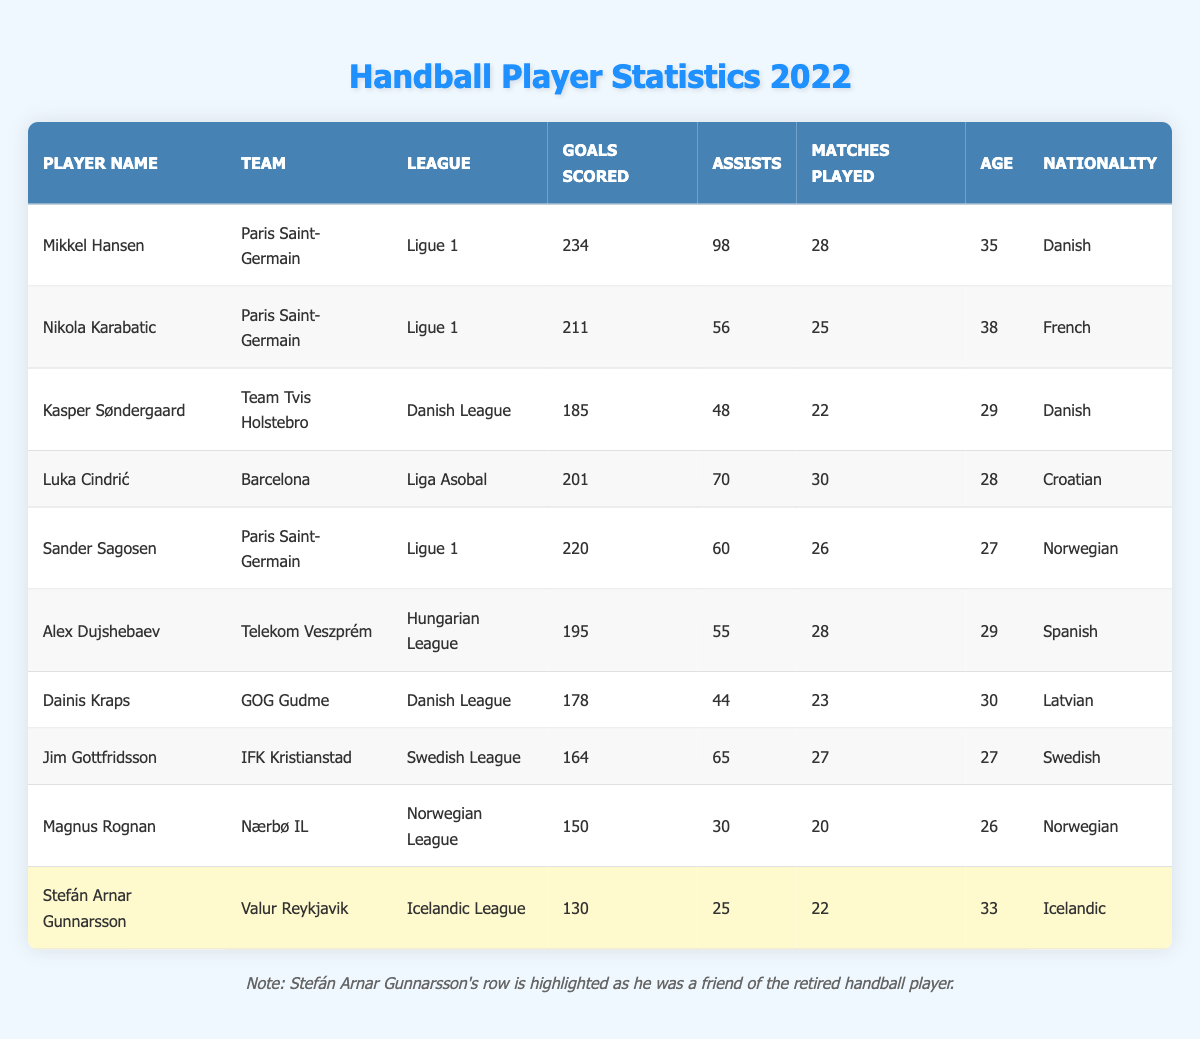What is the total number of goals scored by Mikkel Hansen? Mikkel Hansen's goals scored can be found directly in his row of the table. He scored 234 goals.
Answer: 234 Which player has the most assists in the league? To determine which player has the most assists, we look at the "Assists" column. Mikkel Hansen has 98 assists, more than any other player listed.
Answer: Yes, Mikkel Hansen has the most assists How many matches did Luka Cindrić play? Luka Cindrić's matches played can be found in his row of the table. He played in 30 matches.
Answer: 30 What is the average age of all players in the table? To find the average age, we first sum the ages of all players (35 + 38 + 29 + 28 + 27 + 29 + 30 + 27 + 26 + 33 =  332) which gives us 332. There are 10 players, so we divide by 10: 332 / 10 = 33.2.
Answer: 33.2 Did Stefán Arnar Gunnarsson score more goals than Magnus Rognan? We compare the goals scored by both players. Stefán Arnar Gunnarsson scored 130 goals while Magnus Rognan scored 150 goals. Since 130 is less than 150, Stefán did not score more goals than Magnus.
Answer: No What is the total number of assists by players from the Danish League? The players from the Danish League are Kasper Søndergaard and Dainis Kraps, who recorded 48 and 44 assists, respectively. Adding these values together gives us 48 + 44 = 92 assists in total.
Answer: 92 Which player played the fewest matches and how many did they play? The player with the minimum number of matches played is Magnus Rognan, who played 20 matches. Comparing the "Matches Played" column, it's clear Magnus has the least number.
Answer: 20 Is there a player who scored exactly 150 goals? Looking through the "Goals Scored" column, we check each score. Notably, Magnus Rognan scored 150 goals. Thus, the answer is yes.
Answer: Yes How many more goals did Sander Sagosen score compared to Dainis Kraps? To find the difference, we subtract Dainis Kraps's goals (178) from Sander Sagosen's goals (220). Therefore, 220 - 178 = 42. Sander Sagosen scored 42 more goals.
Answer: 42 